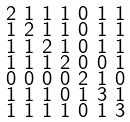Convert formula to latex. <formula><loc_0><loc_0><loc_500><loc_500>\begin{smallmatrix} 2 & 1 & 1 & 1 & 0 & 1 & 1 \\ 1 & 2 & 1 & 1 & 0 & 1 & 1 \\ 1 & 1 & 2 & 1 & 0 & 1 & 1 \\ 1 & 1 & 1 & 2 & 0 & 0 & 1 \\ 0 & 0 & 0 & 0 & 2 & 1 & 0 \\ 1 & 1 & 1 & 0 & 1 & 3 & 1 \\ 1 & 1 & 1 & 1 & 0 & 1 & 3 \end{smallmatrix}</formula> 